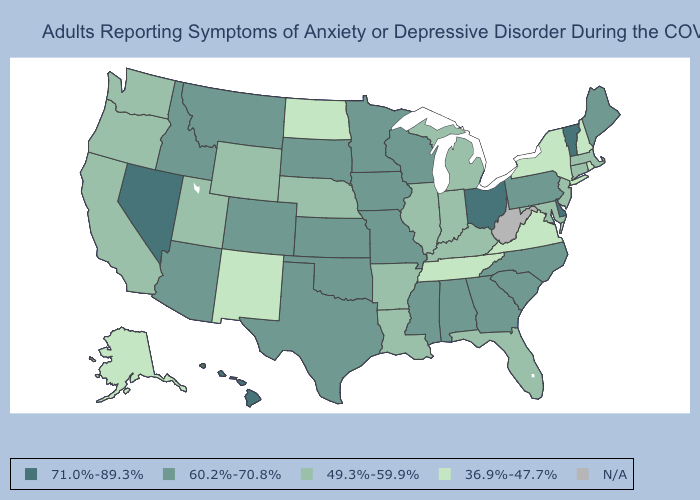What is the value of Tennessee?
Be succinct. 36.9%-47.7%. Which states have the lowest value in the USA?
Quick response, please. Alaska, New Hampshire, New Mexico, New York, North Dakota, Rhode Island, Tennessee, Virginia. Name the states that have a value in the range 60.2%-70.8%?
Answer briefly. Alabama, Arizona, Colorado, Georgia, Idaho, Iowa, Kansas, Maine, Minnesota, Mississippi, Missouri, Montana, North Carolina, Oklahoma, Pennsylvania, South Carolina, South Dakota, Texas, Wisconsin. How many symbols are there in the legend?
Short answer required. 5. Does Maine have the highest value in the Northeast?
Write a very short answer. No. Among the states that border Georgia , which have the highest value?
Concise answer only. Alabama, North Carolina, South Carolina. Name the states that have a value in the range 36.9%-47.7%?
Give a very brief answer. Alaska, New Hampshire, New Mexico, New York, North Dakota, Rhode Island, Tennessee, Virginia. Does Delaware have the highest value in the South?
Short answer required. Yes. How many symbols are there in the legend?
Be succinct. 5. Name the states that have a value in the range N/A?
Be succinct. West Virginia. Which states hav the highest value in the MidWest?
Be succinct. Ohio. Among the states that border New Jersey , which have the highest value?
Give a very brief answer. Delaware. What is the value of New Mexico?
Be succinct. 36.9%-47.7%. Name the states that have a value in the range 36.9%-47.7%?
Give a very brief answer. Alaska, New Hampshire, New Mexico, New York, North Dakota, Rhode Island, Tennessee, Virginia. 